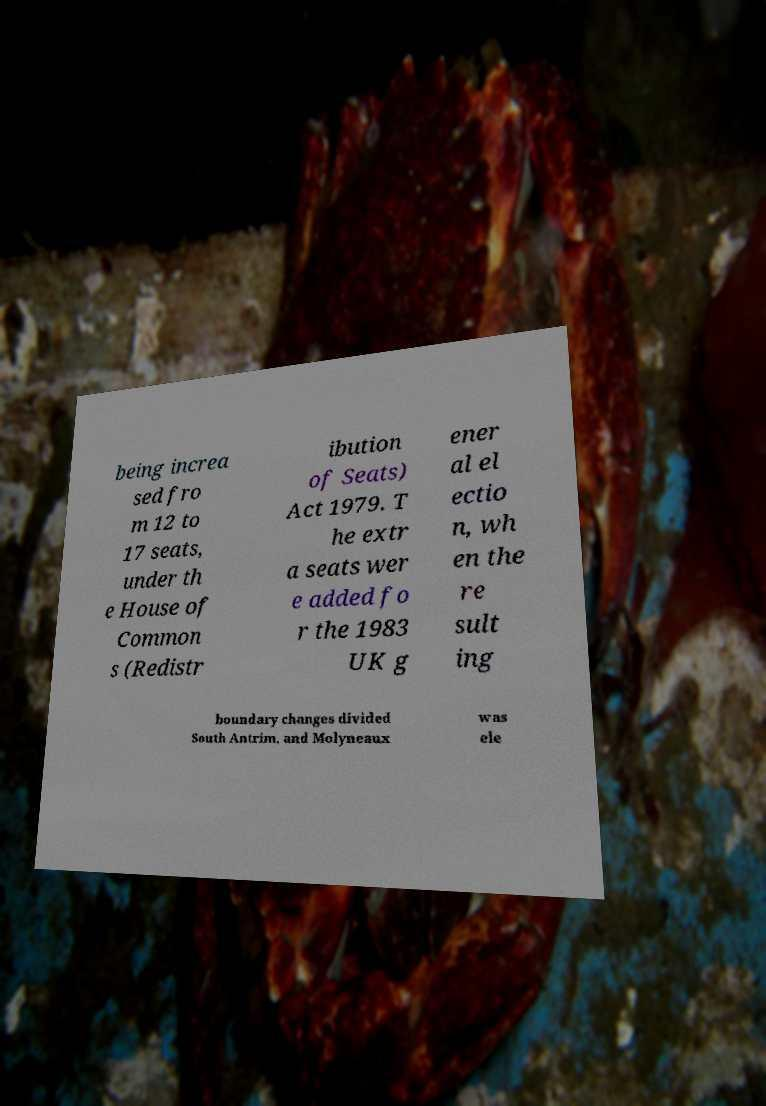Please identify and transcribe the text found in this image. being increa sed fro m 12 to 17 seats, under th e House of Common s (Redistr ibution of Seats) Act 1979. T he extr a seats wer e added fo r the 1983 UK g ener al el ectio n, wh en the re sult ing boundary changes divided South Antrim, and Molyneaux was ele 